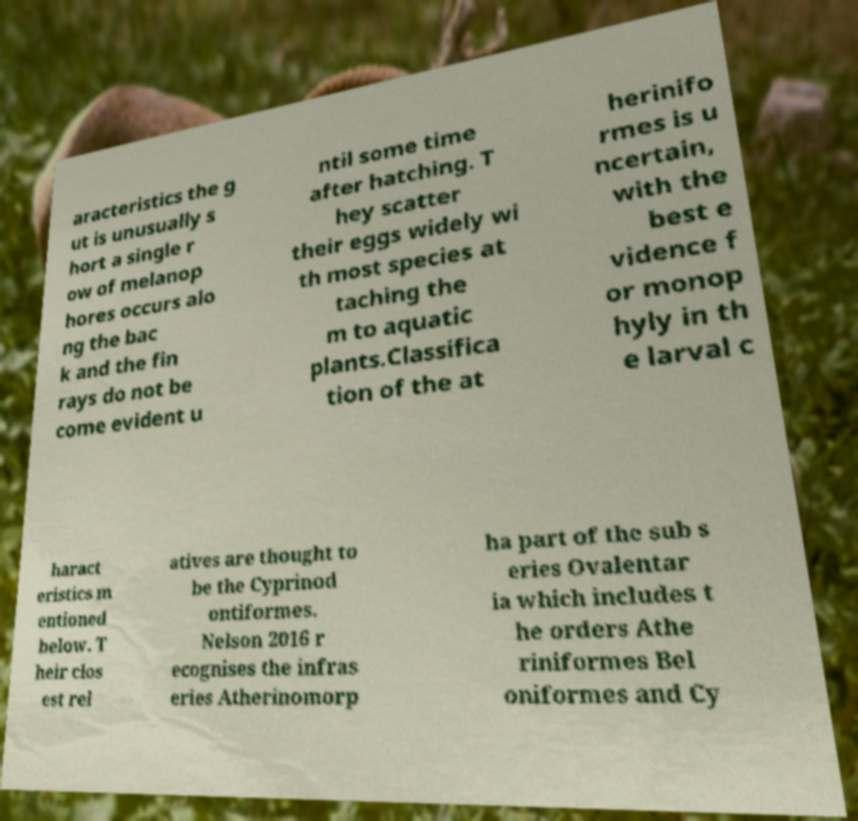Please identify and transcribe the text found in this image. aracteristics the g ut is unusually s hort a single r ow of melanop hores occurs alo ng the bac k and the fin rays do not be come evident u ntil some time after hatching. T hey scatter their eggs widely wi th most species at taching the m to aquatic plants.Classifica tion of the at herinifo rmes is u ncertain, with the best e vidence f or monop hyly in th e larval c haract eristics m entioned below. T heir clos est rel atives are thought to be the Cyprinod ontiformes. Nelson 2016 r ecognises the infras eries Atherinomorp ha part of the sub s eries Ovalentar ia which includes t he orders Athe riniformes Bel oniformes and Cy 